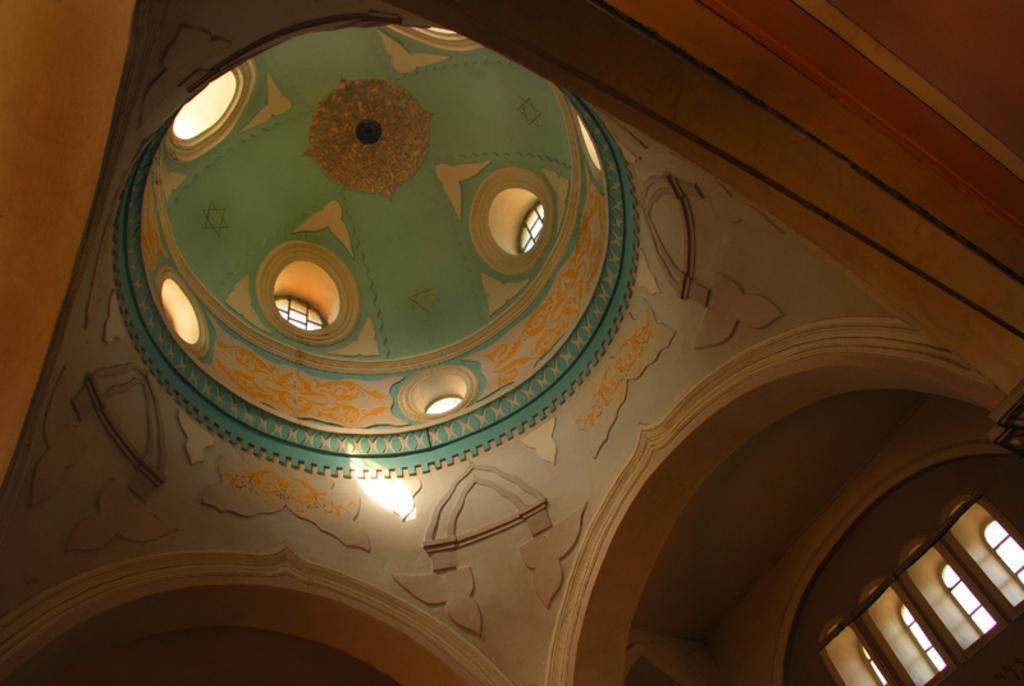Please provide a concise description of this image. In this picture there is a building. At the top there is a floral design on the roof. On the right side of the image there are windows and there is a rod. 